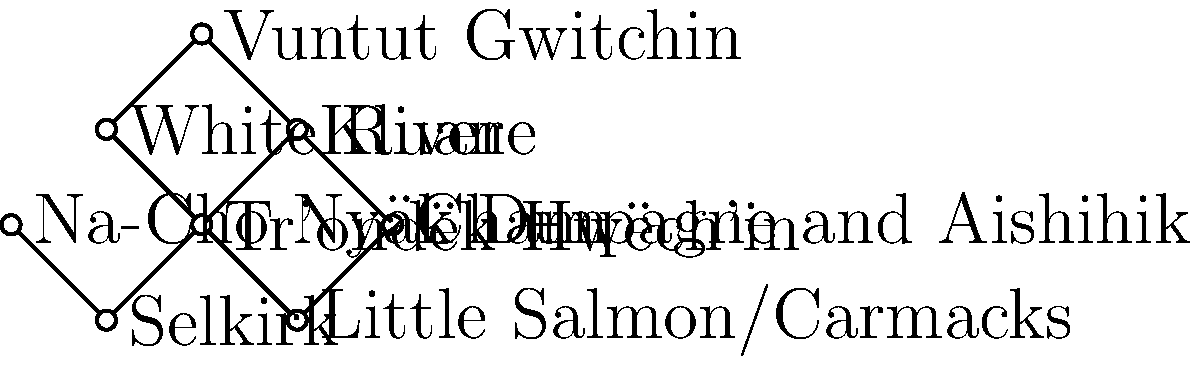In the force-directed graph representing the interconnected relationships between First Nations tribes in Yukon, which tribe appears to have the highest degree centrality (i.e., the most direct connections to other tribes)? To determine which tribe has the highest degree centrality, we need to follow these steps:

1. Understand degree centrality: In graph theory, degree centrality is a measure of the number of direct connections a node has to other nodes in the network.

2. Count connections for each tribe:
   a. Tr'ondëk Hwëch'in: 4 connections (Kluane, White River, Selkirk, Little Salmon/Carmacks)
   b. Kluane: 3 connections (Tr'ondëk Hwëch'in, Vuntut Gwitchin, Champagne and Aishihik)
   c. White River: 2 connections (Tr'ondëk Hwëch'in, Vuntut Gwitchin)
   d. Selkirk: 2 connections (Tr'ondëk Hwëch'in, Na-Cho Nyäk Dun)
   e. Little Salmon/Carmacks: 2 connections (Tr'ondëk Hwëch'in, Champagne and Aishihik)
   f. Vuntut Gwitchin: 2 connections (Kluane, White River)
   g. Champagne and Aishihik: 2 connections (Kluane, Little Salmon/Carmacks)
   h. Na-Cho Nyäk Dun: 1 connection (Selkirk)

3. Identify the highest number of connections: The tribe with the most connections is Tr'ondëk Hwëch'in with 4 direct connections.

Therefore, the tribe with the highest degree centrality in this force-directed graph is Tr'ondëk Hwëch'in.
Answer: Tr'ondëk Hwëch'in 